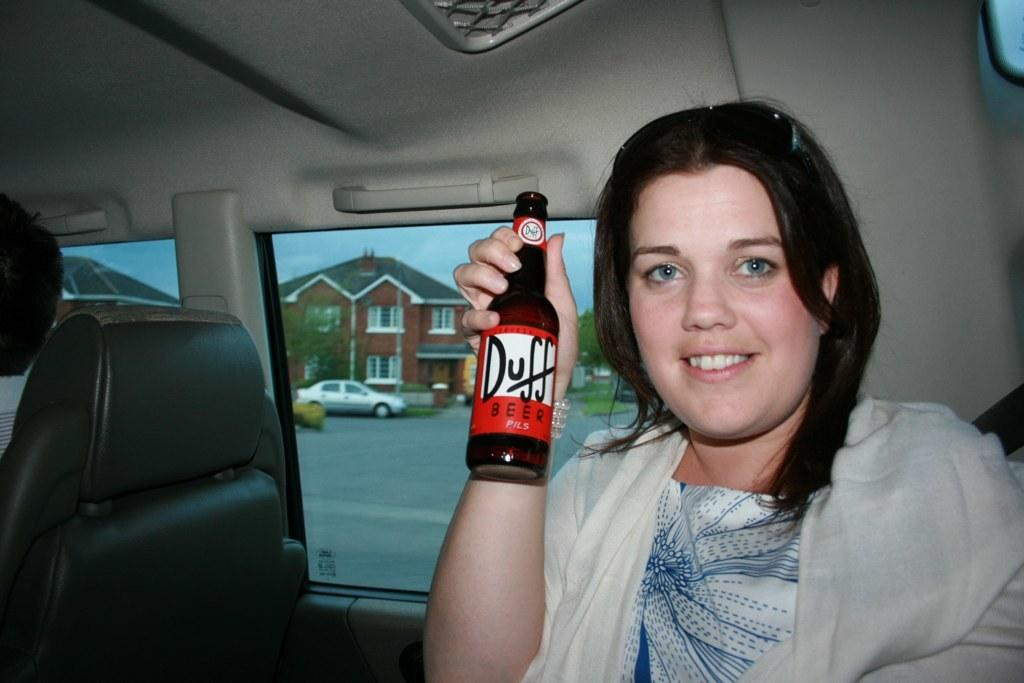Who is present in the image? There is a woman in the image. What is the woman holding in the image? The woman is holding a bottle. What can be seen in the background of the image? There is a car and a building in the background of the image. What part of the natural environment is visible in the image? The sky is visible in the image. What advice is the woman giving to the soldiers during the battle in the image? There is no battle or soldiers present in the image, and the woman is not giving any advice. 